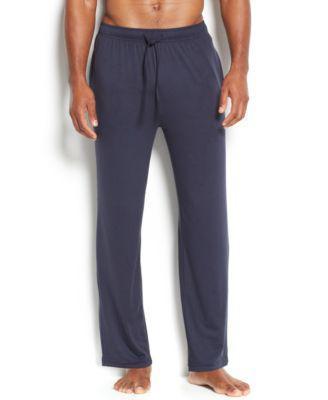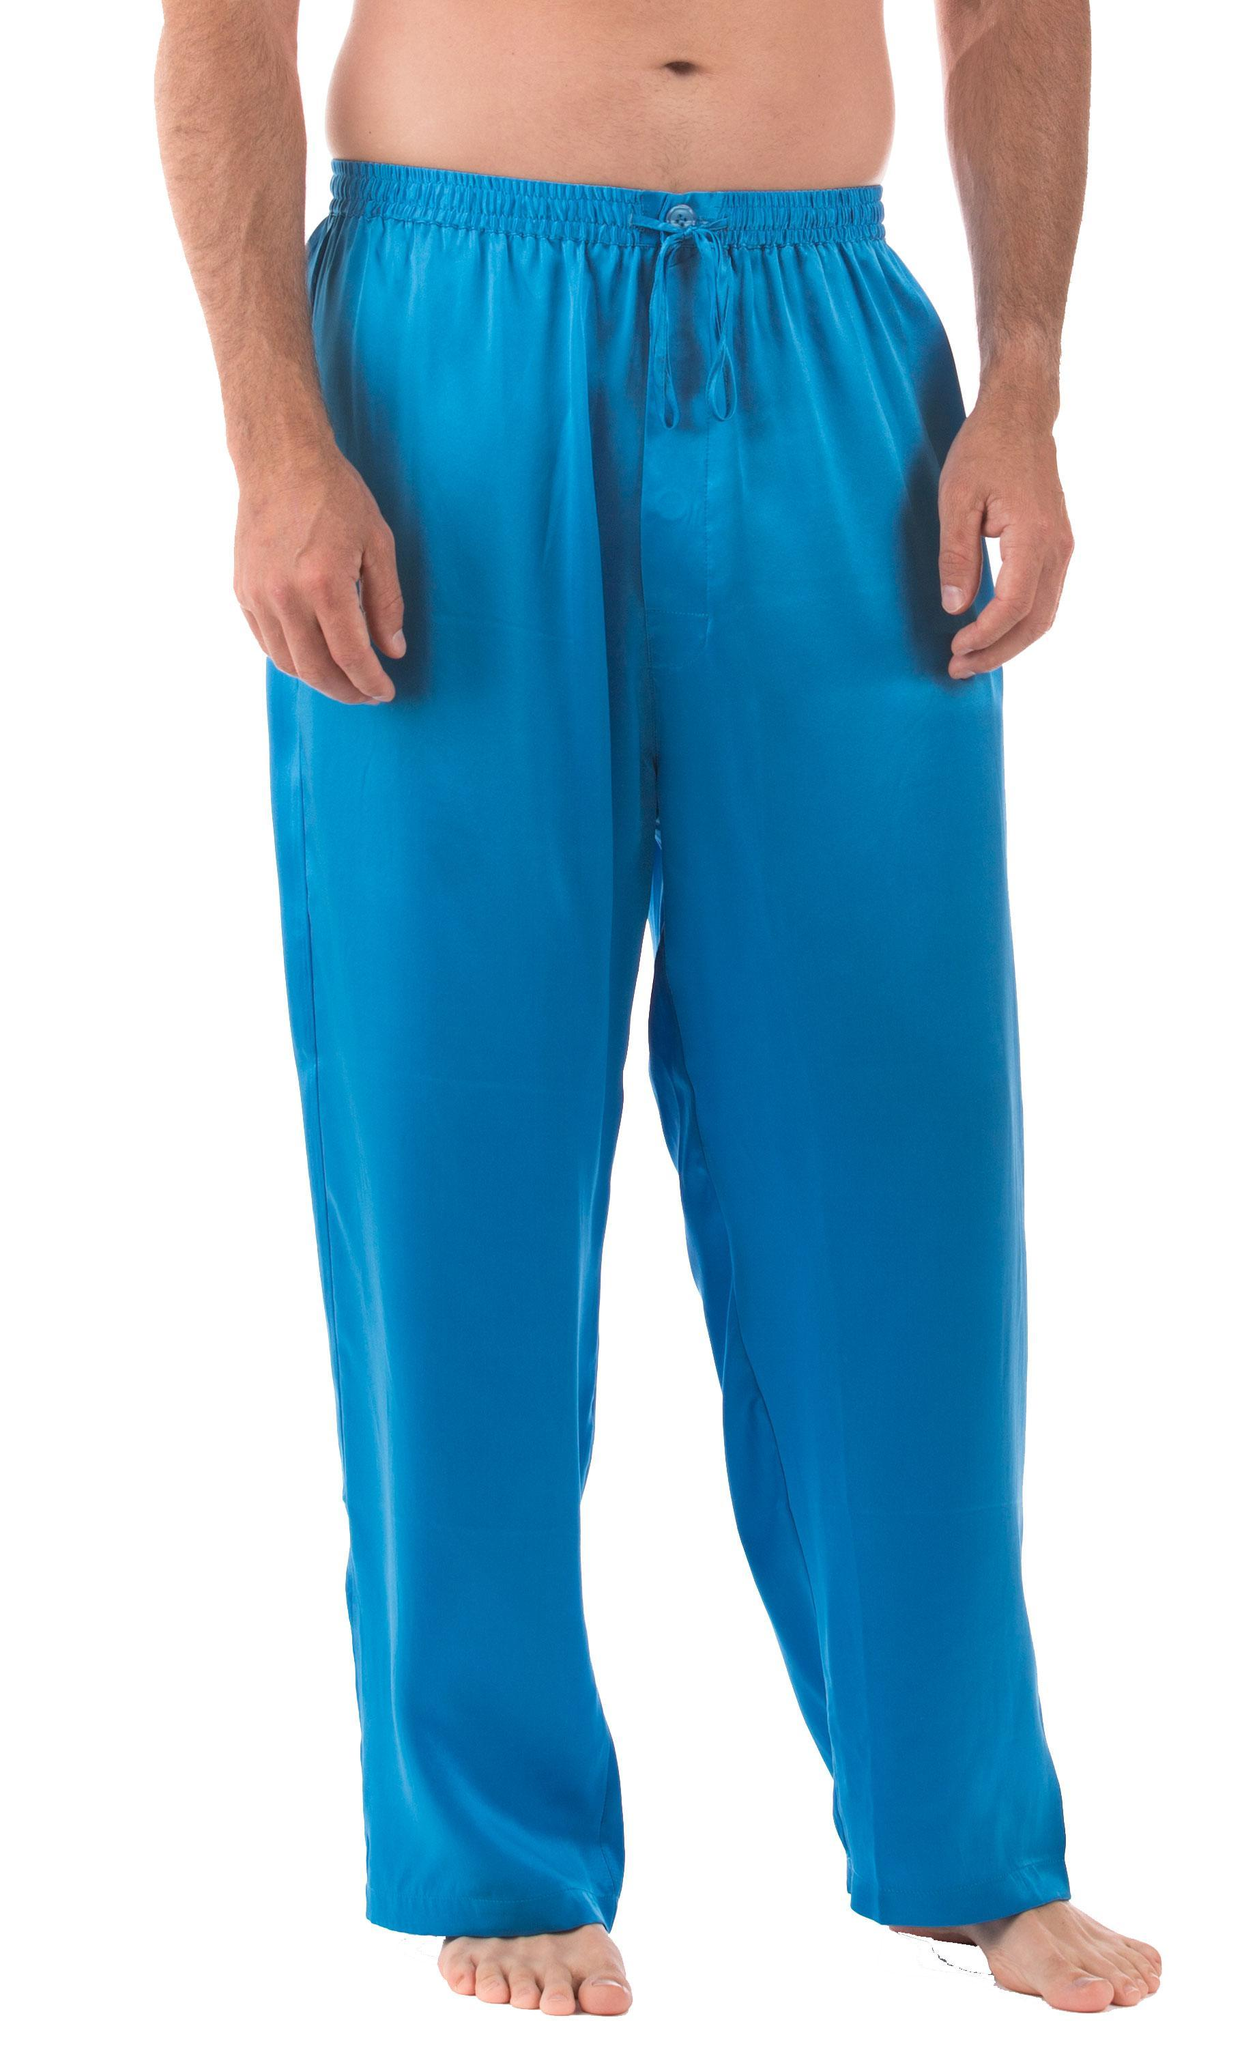The first image is the image on the left, the second image is the image on the right. Evaluate the accuracy of this statement regarding the images: "There are two pairs of pants". Is it true? Answer yes or no. Yes. 